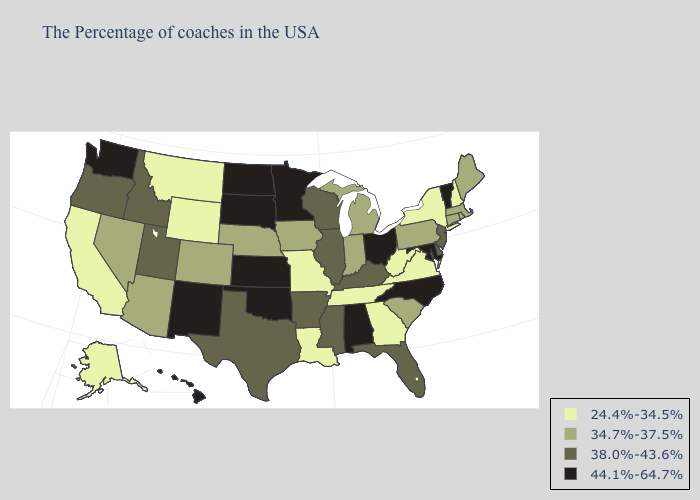What is the lowest value in states that border Kansas?
Quick response, please. 24.4%-34.5%. Name the states that have a value in the range 34.7%-37.5%?
Be succinct. Maine, Massachusetts, Rhode Island, Connecticut, Pennsylvania, South Carolina, Michigan, Indiana, Iowa, Nebraska, Colorado, Arizona, Nevada. Name the states that have a value in the range 44.1%-64.7%?
Be succinct. Vermont, Maryland, North Carolina, Ohio, Alabama, Minnesota, Kansas, Oklahoma, South Dakota, North Dakota, New Mexico, Washington, Hawaii. What is the highest value in the South ?
Keep it brief. 44.1%-64.7%. Among the states that border Arizona , does New Mexico have the highest value?
Quick response, please. Yes. Name the states that have a value in the range 24.4%-34.5%?
Be succinct. New Hampshire, New York, Virginia, West Virginia, Georgia, Tennessee, Louisiana, Missouri, Wyoming, Montana, California, Alaska. What is the value of South Dakota?
Answer briefly. 44.1%-64.7%. What is the highest value in the South ?
Quick response, please. 44.1%-64.7%. What is the value of Washington?
Keep it brief. 44.1%-64.7%. Does New York have the lowest value in the Northeast?
Concise answer only. Yes. Does the map have missing data?
Write a very short answer. No. Among the states that border Michigan , which have the lowest value?
Concise answer only. Indiana. Which states have the lowest value in the USA?
Concise answer only. New Hampshire, New York, Virginia, West Virginia, Georgia, Tennessee, Louisiana, Missouri, Wyoming, Montana, California, Alaska. Among the states that border Georgia , which have the lowest value?
Keep it brief. Tennessee. What is the lowest value in the Northeast?
Answer briefly. 24.4%-34.5%. 